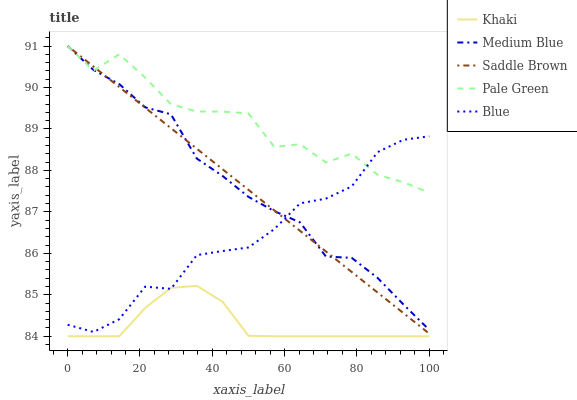Does Khaki have the minimum area under the curve?
Answer yes or no. Yes. Does Pale Green have the maximum area under the curve?
Answer yes or no. Yes. Does Pale Green have the minimum area under the curve?
Answer yes or no. No. Does Khaki have the maximum area under the curve?
Answer yes or no. No. Is Saddle Brown the smoothest?
Answer yes or no. Yes. Is Pale Green the roughest?
Answer yes or no. Yes. Is Khaki the smoothest?
Answer yes or no. No. Is Khaki the roughest?
Answer yes or no. No. Does Pale Green have the lowest value?
Answer yes or no. No. Does Khaki have the highest value?
Answer yes or no. No. Is Khaki less than Medium Blue?
Answer yes or no. Yes. Is Pale Green greater than Khaki?
Answer yes or no. Yes. Does Khaki intersect Medium Blue?
Answer yes or no. No. 